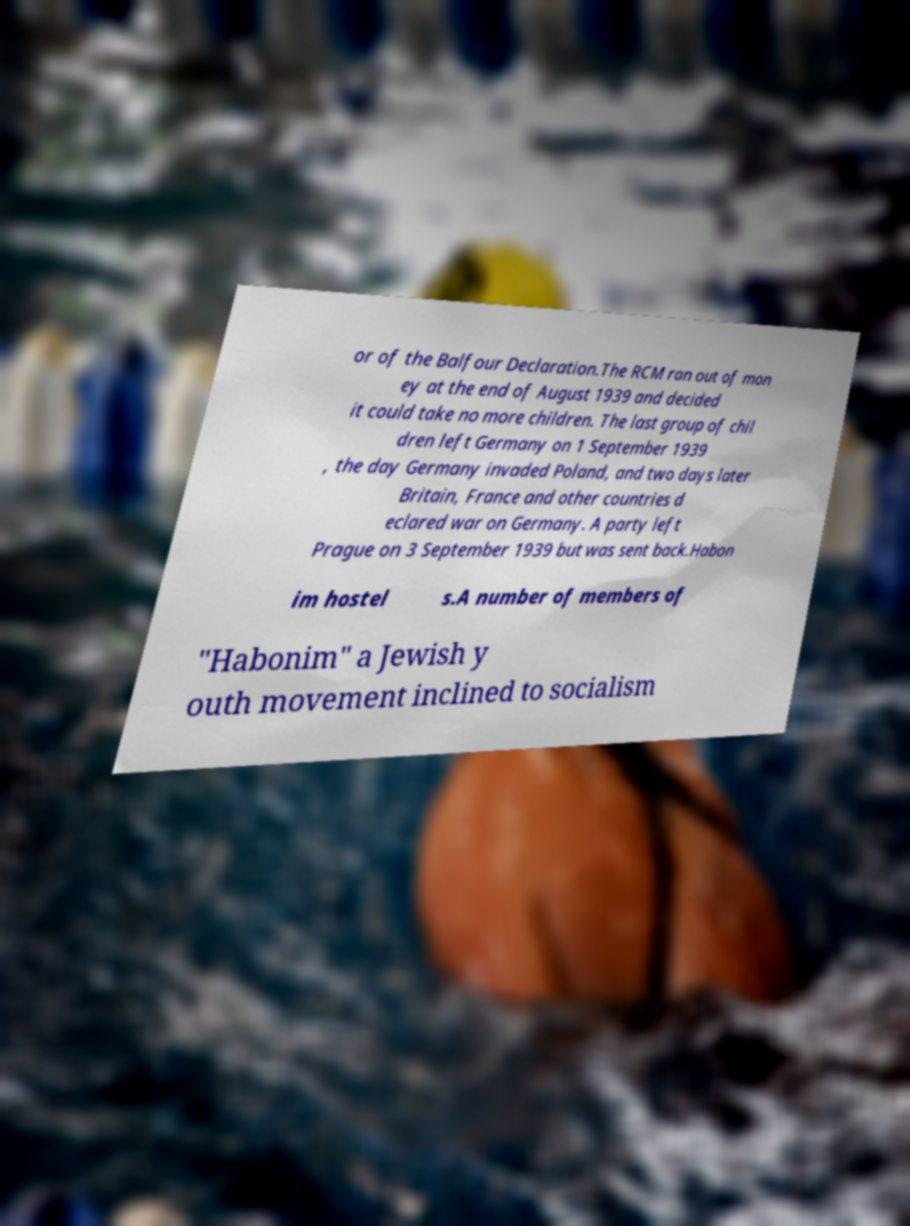For documentation purposes, I need the text within this image transcribed. Could you provide that? or of the Balfour Declaration.The RCM ran out of mon ey at the end of August 1939 and decided it could take no more children. The last group of chil dren left Germany on 1 September 1939 , the day Germany invaded Poland, and two days later Britain, France and other countries d eclared war on Germany. A party left Prague on 3 September 1939 but was sent back.Habon im hostel s.A number of members of "Habonim" a Jewish y outh movement inclined to socialism 